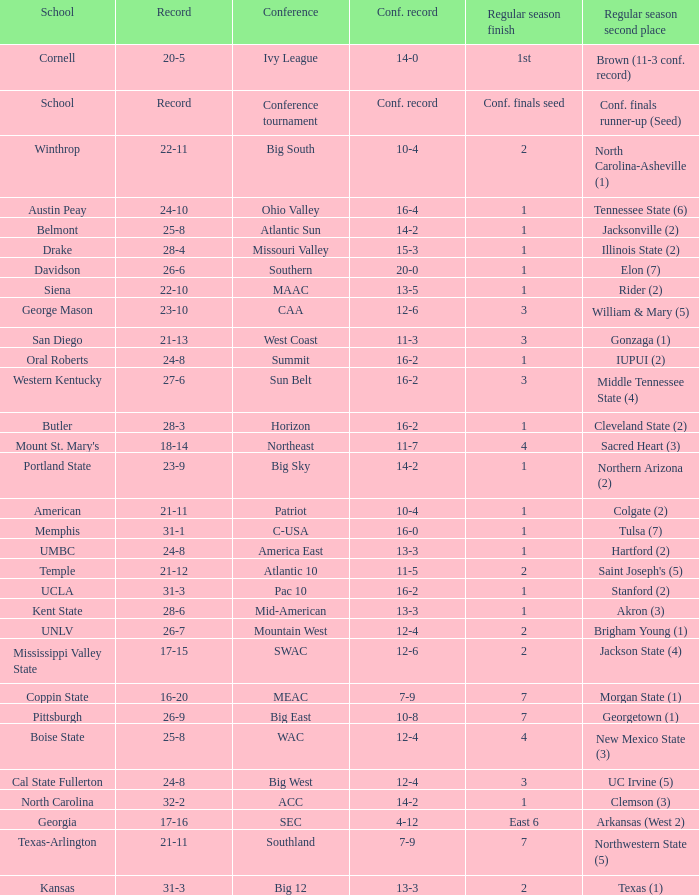For teams in the Sun Belt conference, what is the conference record? 16-2. 